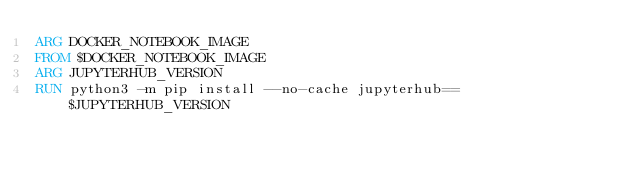Convert code to text. <code><loc_0><loc_0><loc_500><loc_500><_Dockerfile_>ARG DOCKER_NOTEBOOK_IMAGE
FROM $DOCKER_NOTEBOOK_IMAGE
ARG JUPYTERHUB_VERSION
RUN python3 -m pip install --no-cache jupyterhub==$JUPYTERHUB_VERSION
</code> 